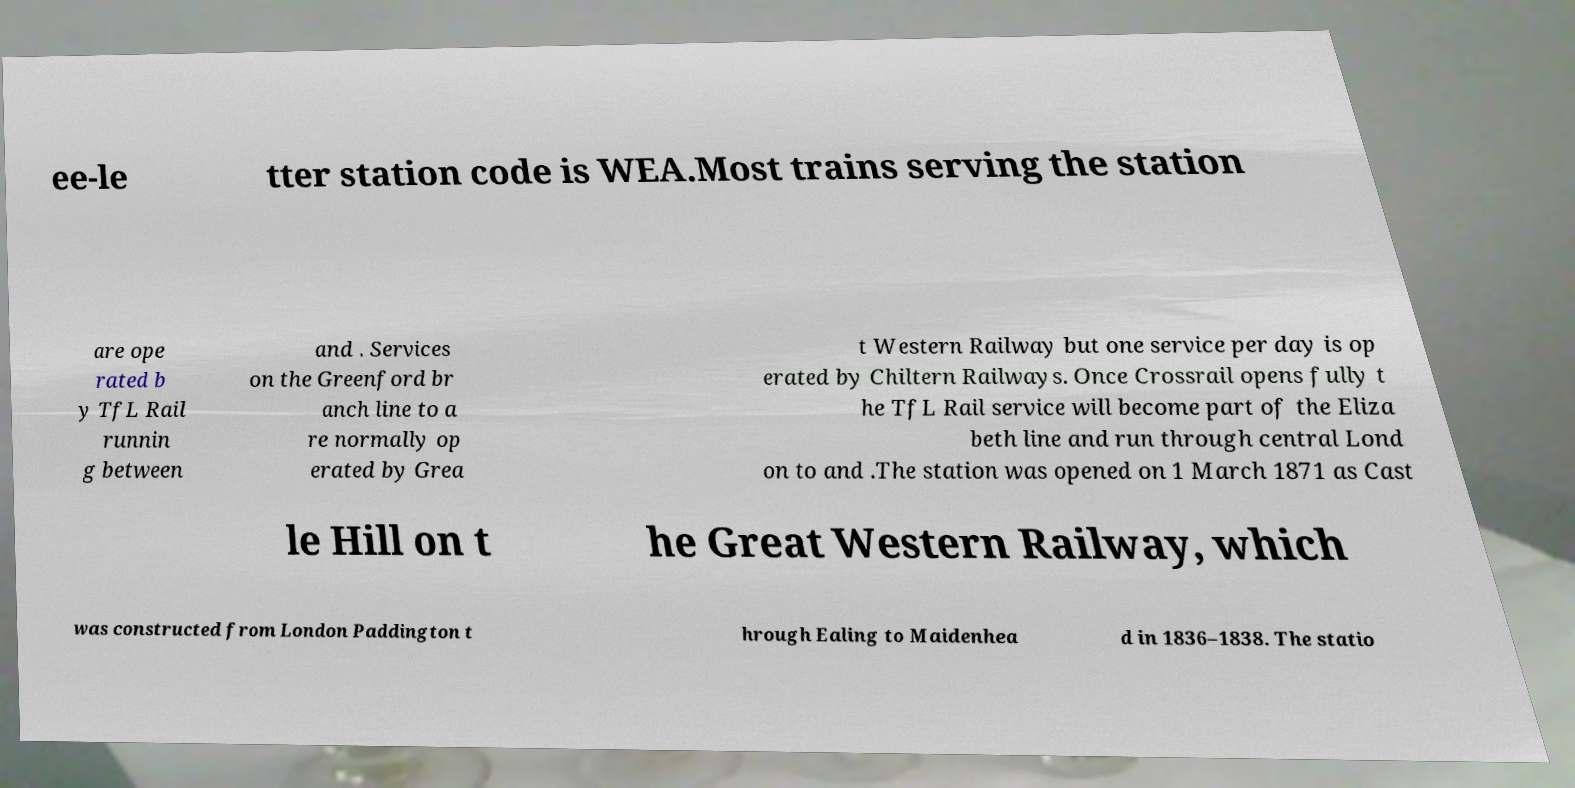There's text embedded in this image that I need extracted. Can you transcribe it verbatim? ee-le tter station code is WEA.Most trains serving the station are ope rated b y TfL Rail runnin g between and . Services on the Greenford br anch line to a re normally op erated by Grea t Western Railway but one service per day is op erated by Chiltern Railways. Once Crossrail opens fully t he TfL Rail service will become part of the Eliza beth line and run through central Lond on to and .The station was opened on 1 March 1871 as Cast le Hill on t he Great Western Railway, which was constructed from London Paddington t hrough Ealing to Maidenhea d in 1836–1838. The statio 